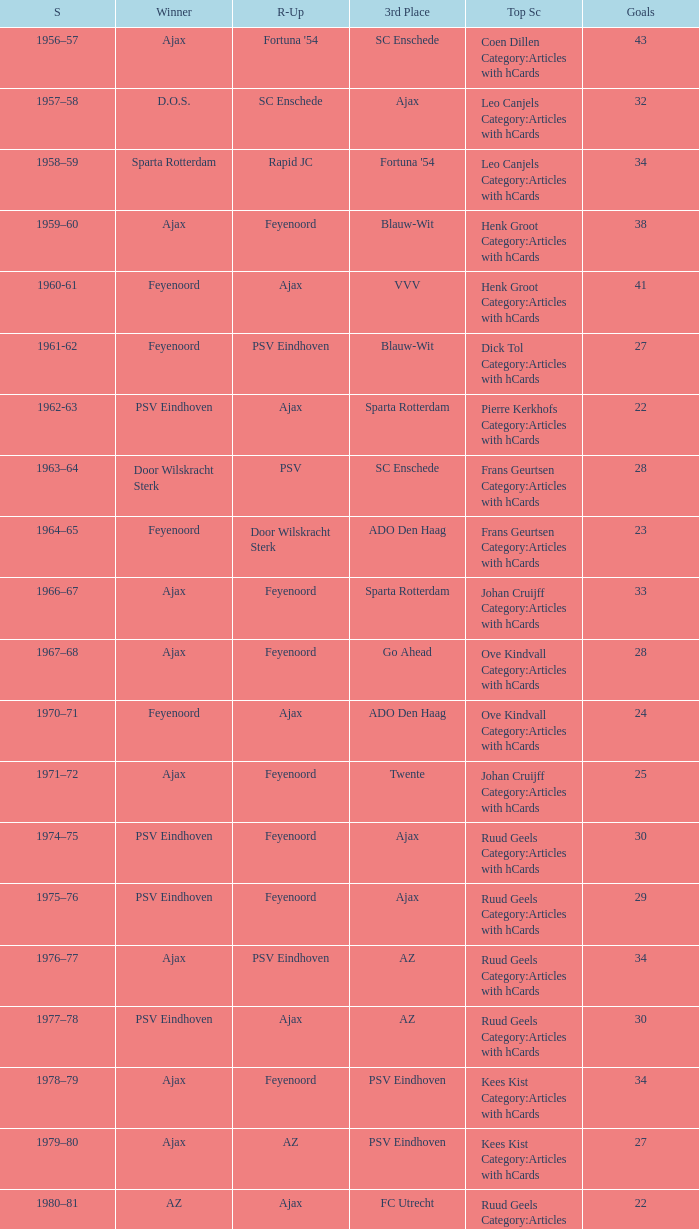When az is the runner up nad feyenoord came in third place how many overall winners are there? 1.0. 